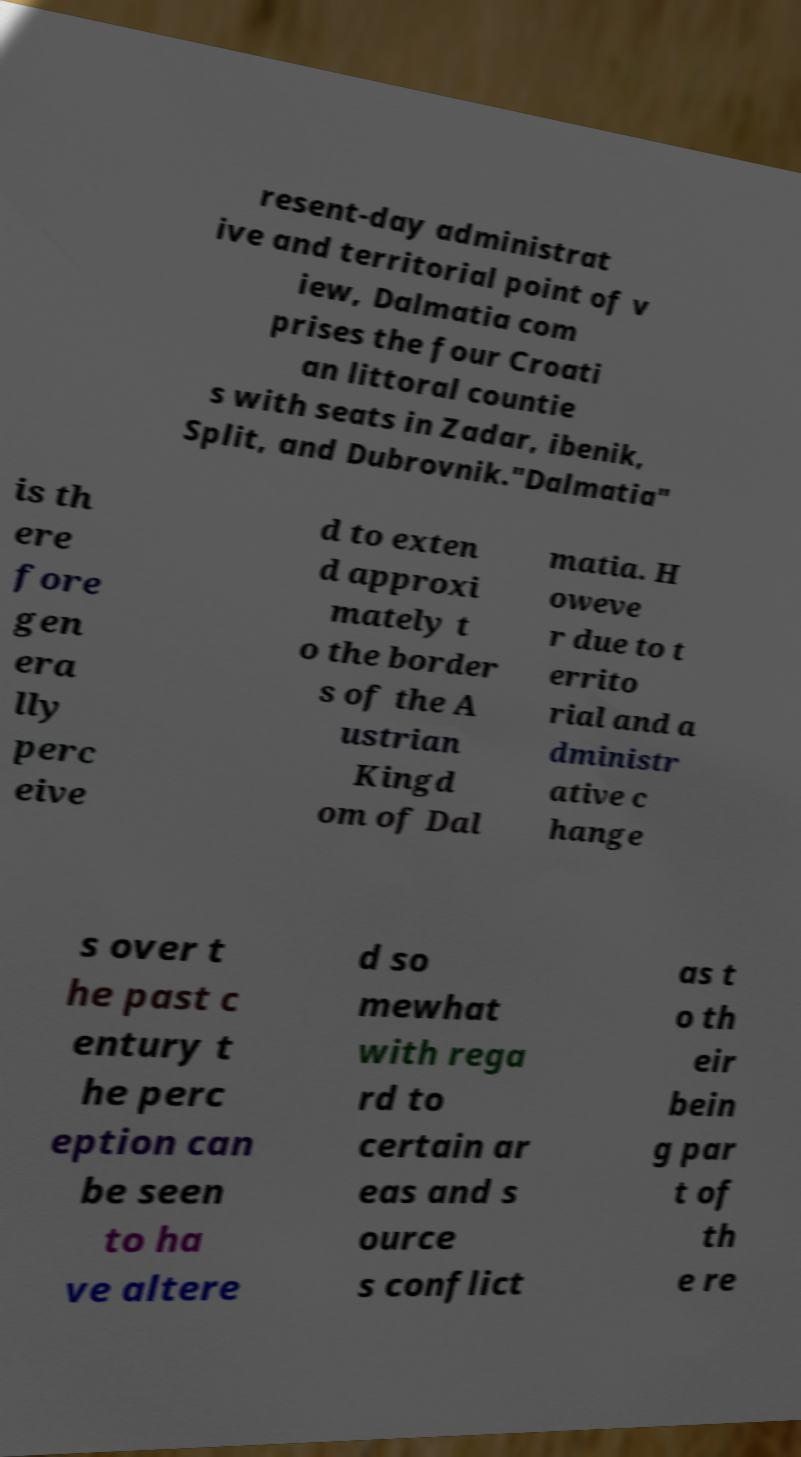What messages or text are displayed in this image? I need them in a readable, typed format. resent-day administrat ive and territorial point of v iew, Dalmatia com prises the four Croati an littoral countie s with seats in Zadar, ibenik, Split, and Dubrovnik."Dalmatia" is th ere fore gen era lly perc eive d to exten d approxi mately t o the border s of the A ustrian Kingd om of Dal matia. H oweve r due to t errito rial and a dministr ative c hange s over t he past c entury t he perc eption can be seen to ha ve altere d so mewhat with rega rd to certain ar eas and s ource s conflict as t o th eir bein g par t of th e re 